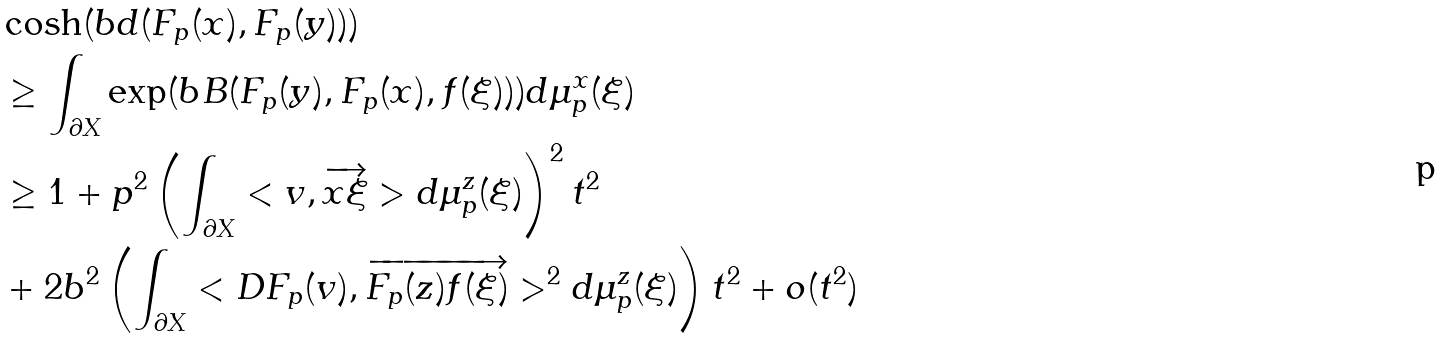Convert formula to latex. <formula><loc_0><loc_0><loc_500><loc_500>& \cosh ( b d ( F _ { p } ( x ) , F _ { p } ( y ) ) ) \\ & \geq \int _ { \partial X } \exp ( b B ( F _ { p } ( y ) , F _ { p } ( x ) , f ( \xi ) ) ) d \mu ^ { x } _ { p } ( \xi ) \\ & \geq 1 + p ^ { 2 } \left ( \int _ { \partial X } < v , \overrightarrow { x \xi } > d \mu ^ { z } _ { p } ( \xi ) \right ) ^ { 2 } t ^ { 2 } \\ & + 2 b ^ { 2 } \left ( \int _ { \partial X } < D F _ { p } ( v ) , \overrightarrow { F _ { p } ( z ) f ( \xi ) } > ^ { 2 } d \mu ^ { z } _ { p } ( \xi ) \right ) t ^ { 2 } + o ( t ^ { 2 } ) \\</formula> 